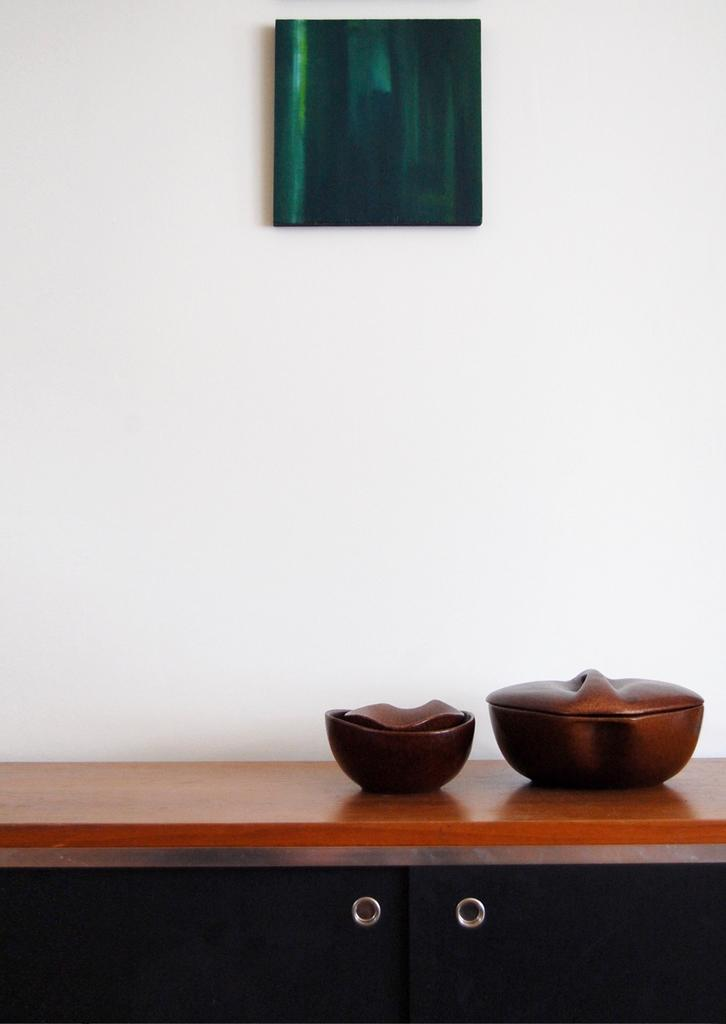How many bowls are visible in the image? There are two bowls in the image. What is the color of the table on which the bowls are placed? The table is brown in color. What can be seen attached to the wall in the image? There is a green color frame attached to the wall. What is the color of the wall in the image? The wall is in white color. What type of animal is being taught in the image? There is no animal or teaching activity present in the image. 